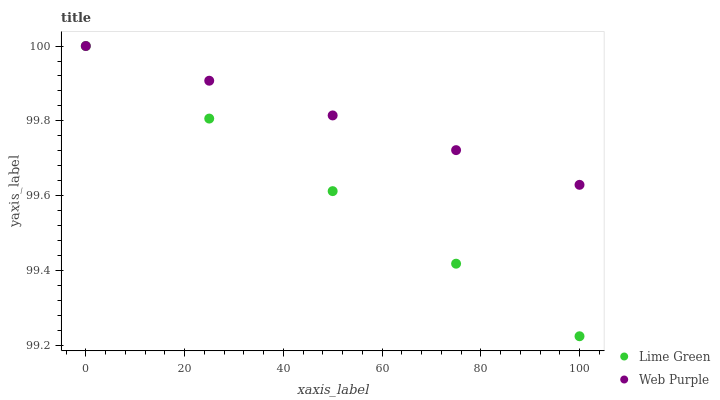Does Lime Green have the minimum area under the curve?
Answer yes or no. Yes. Does Web Purple have the maximum area under the curve?
Answer yes or no. Yes. Does Lime Green have the maximum area under the curve?
Answer yes or no. No. Is Web Purple the smoothest?
Answer yes or no. Yes. Is Lime Green the roughest?
Answer yes or no. Yes. Is Lime Green the smoothest?
Answer yes or no. No. Does Lime Green have the lowest value?
Answer yes or no. Yes. Does Lime Green have the highest value?
Answer yes or no. Yes. Does Web Purple intersect Lime Green?
Answer yes or no. Yes. Is Web Purple less than Lime Green?
Answer yes or no. No. Is Web Purple greater than Lime Green?
Answer yes or no. No. 